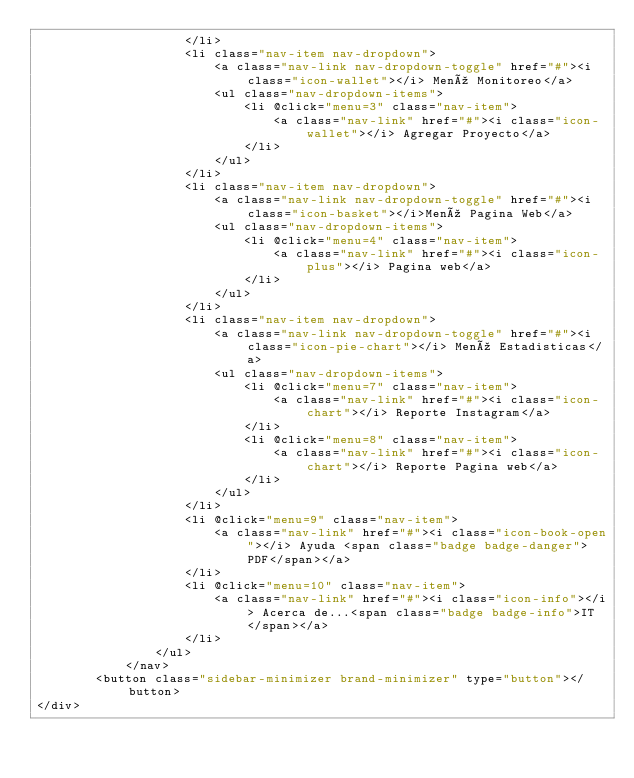<code> <loc_0><loc_0><loc_500><loc_500><_PHP_>                    </li>
                    <li class="nav-item nav-dropdown">
                        <a class="nav-link nav-dropdown-toggle" href="#"><i class="icon-wallet"></i> Menú Monitoreo</a>
                        <ul class="nav-dropdown-items">
                            <li @click="menu=3" class="nav-item">
                                <a class="nav-link" href="#"><i class="icon-wallet"></i> Agregar Proyecto</a>
                            </li>
                        </ul>
                    </li>
                    <li class="nav-item nav-dropdown">
                        <a class="nav-link nav-dropdown-toggle" href="#"><i class="icon-basket"></i>Menú Pagina Web</a>
                        <ul class="nav-dropdown-items">
                            <li @click="menu=4" class="nav-item">
                                <a class="nav-link" href="#"><i class="icon-plus"></i> Pagina web</a>
                            </li>
                        </ul>
                    </li>
                    <li class="nav-item nav-dropdown">
                        <a class="nav-link nav-dropdown-toggle" href="#"><i class="icon-pie-chart"></i> Menú Estadisticas</a>
                        <ul class="nav-dropdown-items">
                            <li @click="menu=7" class="nav-item">
                                <a class="nav-link" href="#"><i class="icon-chart"></i> Reporte Instagram</a>
                            </li>
                            <li @click="menu=8" class="nav-item">
                                <a class="nav-link" href="#"><i class="icon-chart"></i> Reporte Pagina web</a>
                            </li>
                        </ul>
                    </li>
                    <li @click="menu=9" class="nav-item">
                        <a class="nav-link" href="#"><i class="icon-book-open"></i> Ayuda <span class="badge badge-danger">PDF</span></a>
                    </li>
                    <li @click="menu=10" class="nav-item">
                        <a class="nav-link" href="#"><i class="icon-info"></i> Acerca de...<span class="badge badge-info">IT</span></a>
                    </li>
                </ul>
            </nav>
        <button class="sidebar-minimizer brand-minimizer" type="button"></button>
</div></code> 